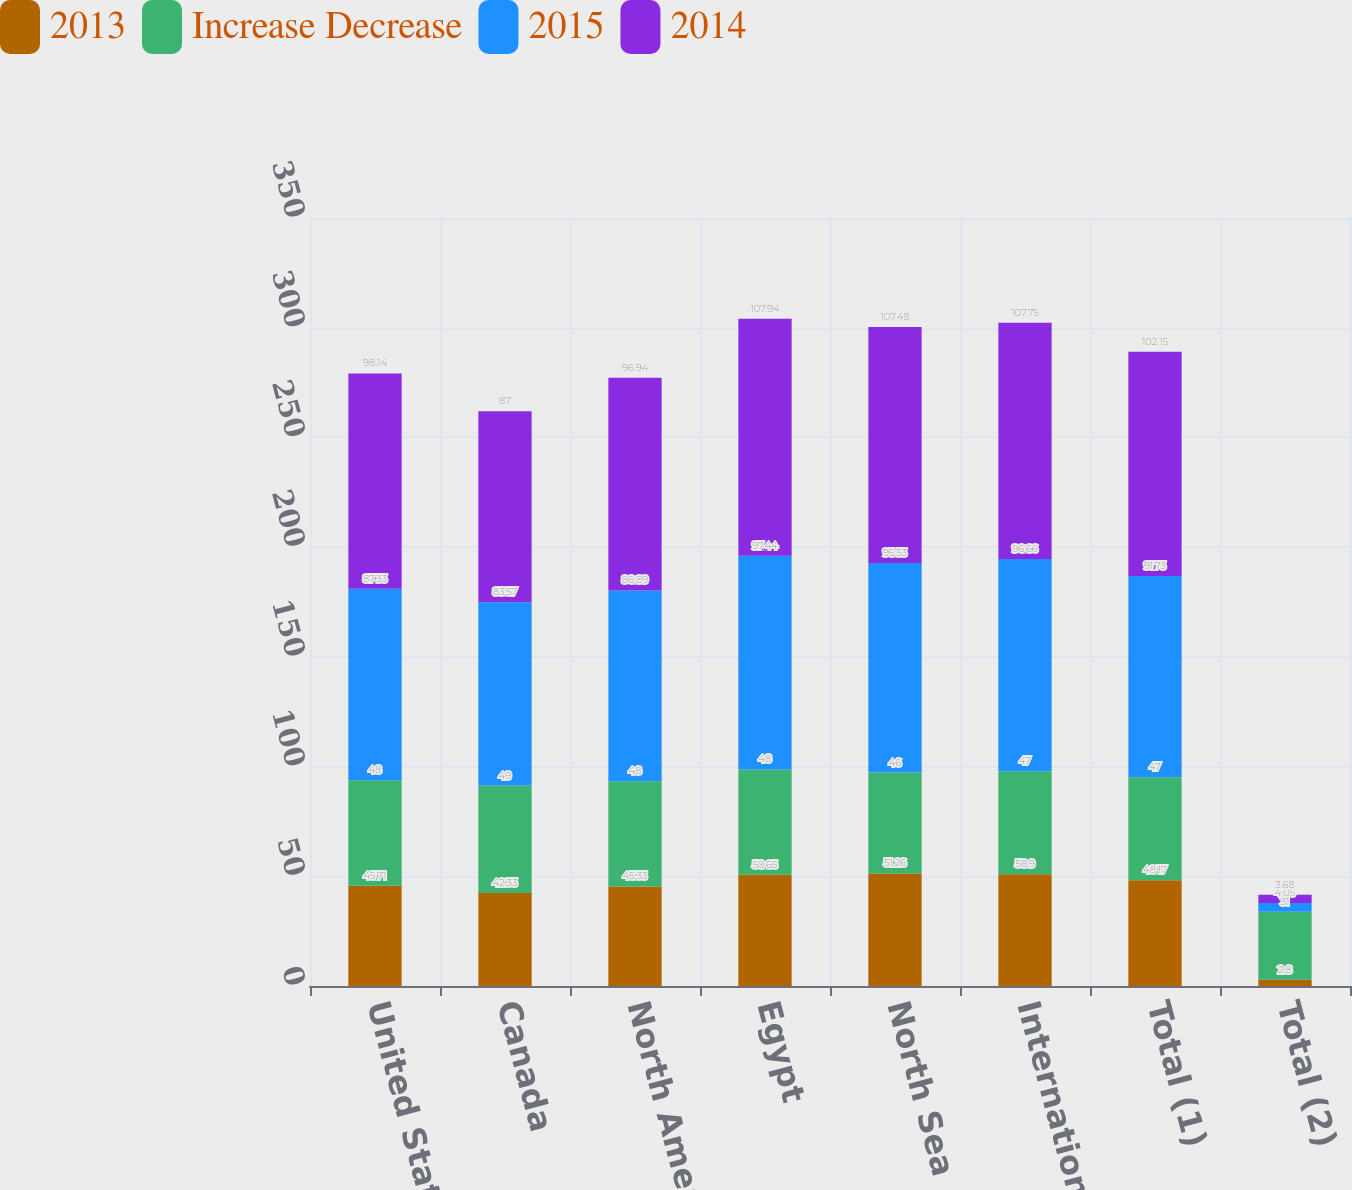Convert chart to OTSL. <chart><loc_0><loc_0><loc_500><loc_500><stacked_bar_chart><ecel><fcel>United States<fcel>Canada<fcel>North America<fcel>Egypt<fcel>North Sea<fcel>International<fcel>Total (1)<fcel>Total (2)<nl><fcel>2013<fcel>45.71<fcel>42.33<fcel>45.33<fcel>50.65<fcel>51.26<fcel>50.9<fcel>48.17<fcel>2.8<nl><fcel>Increase Decrease<fcel>48<fcel>49<fcel>48<fcel>48<fcel>46<fcel>47<fcel>47<fcel>31<nl><fcel>2015<fcel>87.33<fcel>83.57<fcel>86.89<fcel>97.44<fcel>95.53<fcel>96.66<fcel>91.73<fcel>4.05<nl><fcel>2014<fcel>98.14<fcel>87<fcel>96.94<fcel>107.94<fcel>107.48<fcel>107.75<fcel>102.15<fcel>3.68<nl></chart> 